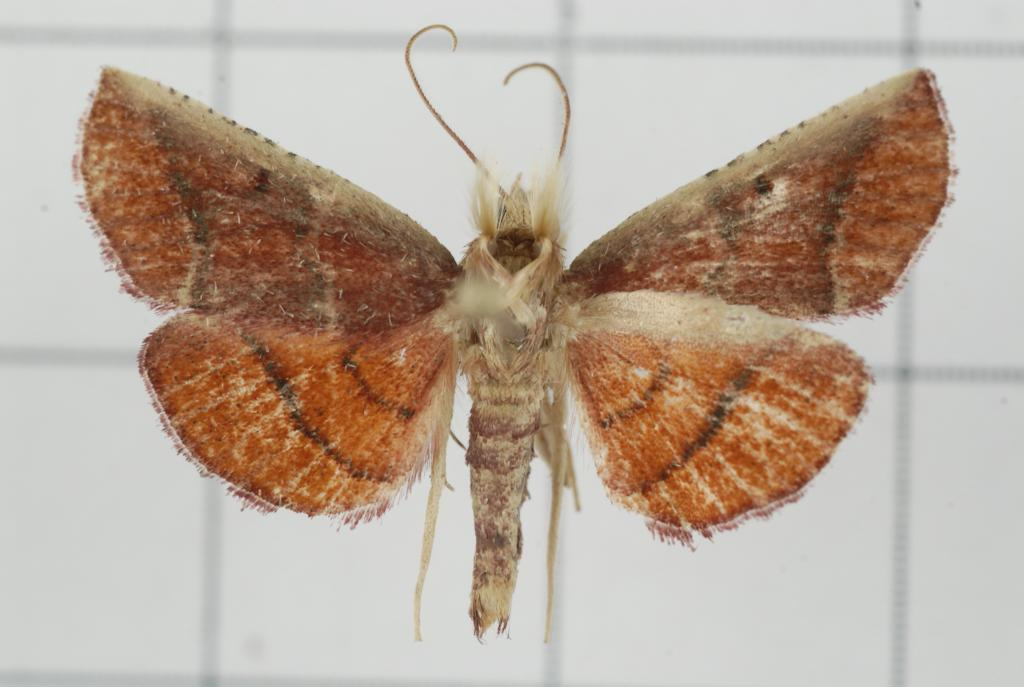What is the main subject of the image? The main subject of the image is a butterfly. What are the wings of the butterfly like? The butterfly has wings. What color is the background of the image? The background of the image is white in color. Where is the patch of cherries located in the image? There is no patch of cherries present in the image. What type of locket is hanging from the butterfly's wings in the image? There is no locket present in the image; it only features a butterfly with wings. 